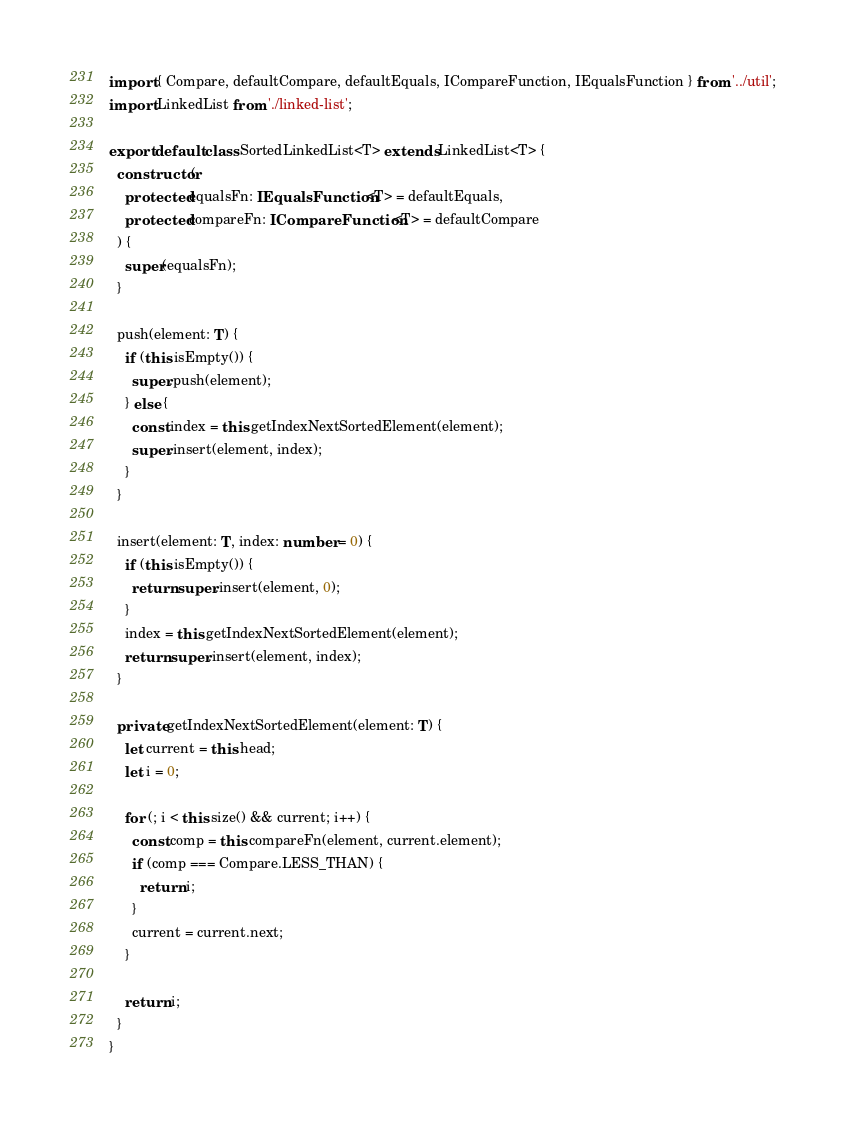<code> <loc_0><loc_0><loc_500><loc_500><_TypeScript_>import { Compare, defaultCompare, defaultEquals, ICompareFunction, IEqualsFunction } from '../util';
import LinkedList from './linked-list';

export default class SortedLinkedList<T> extends LinkedList<T> {
  constructor(
    protected equalsFn: IEqualsFunction<T> = defaultEquals,
    protected compareFn: ICompareFunction<T> = defaultCompare
  ) {
    super(equalsFn);
  }

  push(element: T) {
    if (this.isEmpty()) {
      super.push(element);
    } else {
      const index = this.getIndexNextSortedElement(element);
      super.insert(element, index);
    }
  }

  insert(element: T, index: number = 0) {
    if (this.isEmpty()) {
      return super.insert(element, 0);
    }
    index = this.getIndexNextSortedElement(element);
    return super.insert(element, index);
  }

  private getIndexNextSortedElement(element: T) {
    let current = this.head;
    let i = 0;

    for (; i < this.size() && current; i++) {
      const comp = this.compareFn(element, current.element);
      if (comp === Compare.LESS_THAN) {
        return i;
      }
      current = current.next;
    }

    return i;
  }
}
</code> 